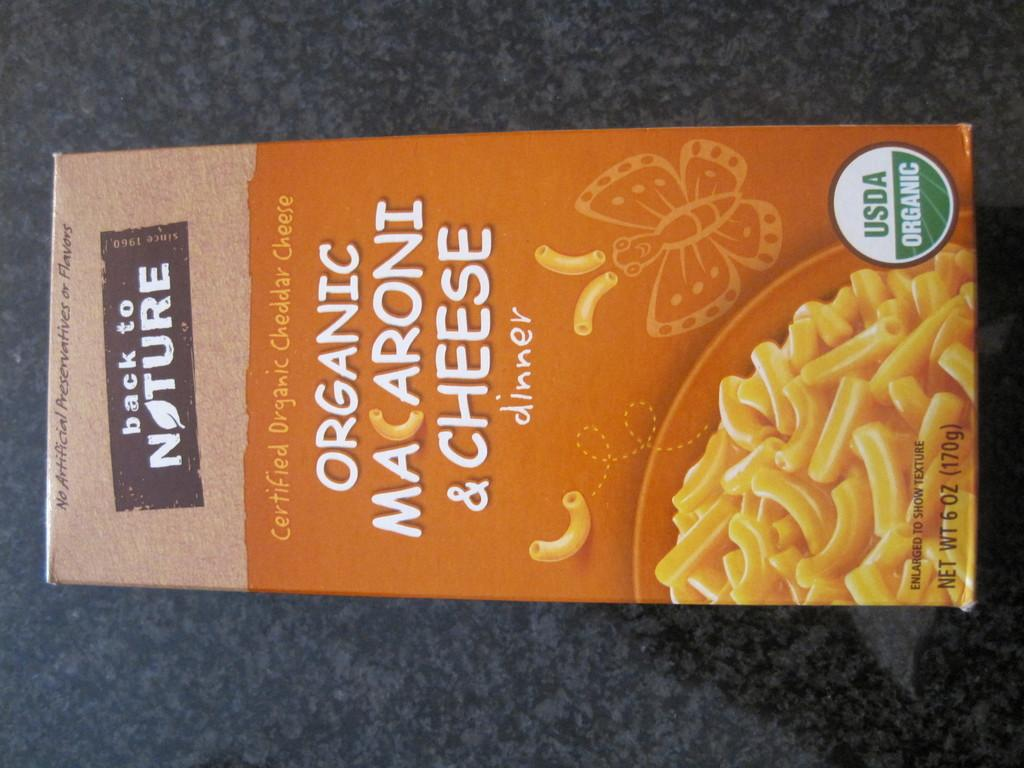<image>
Create a compact narrative representing the image presented. A box of Back to Nature Organic Mac and Cheese. 